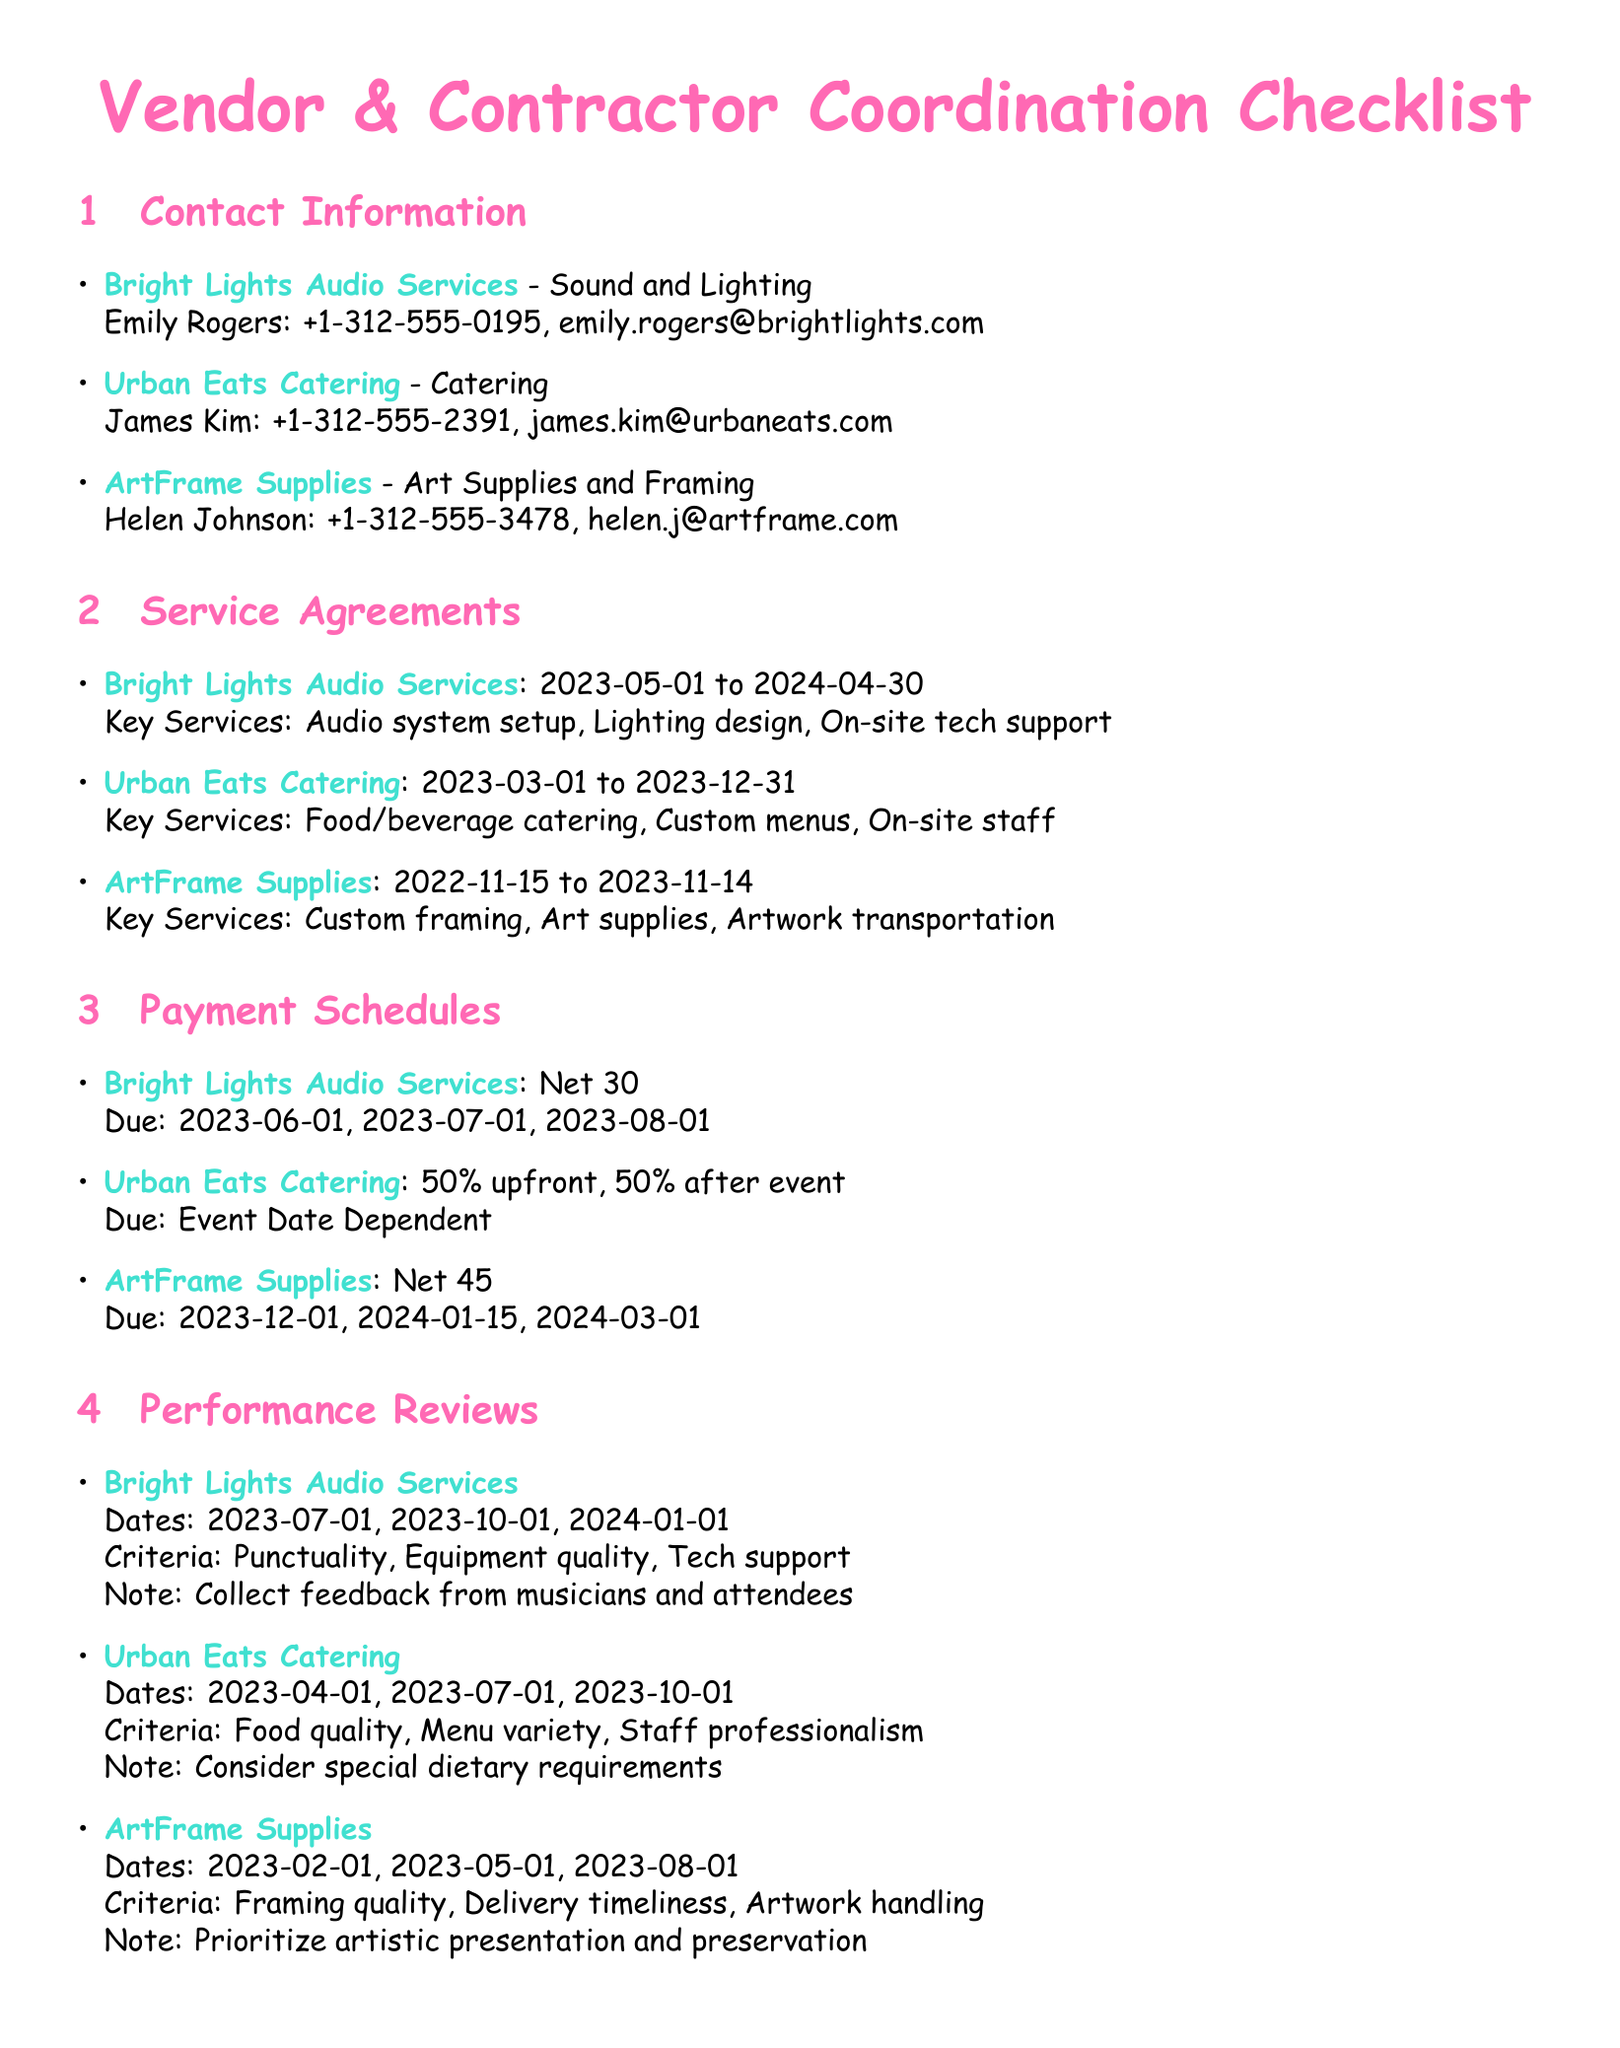what is the contact number for Urban Eats Catering? The contact number is the specific information provided for Urban Eats Catering among other vendors in the checklist.
Answer: +1-312-555-2391 what is the service end date for Bright Lights Audio Services? The service end date is mentioned in the service agreements section for Bright Lights Audio Services.
Answer: 2024-04-30 how often are payments due for ArtFrame Supplies? This question requires synthesizing the payment schedule details for ArtFrame Supplies to determine the payment frequency.
Answer: Net 45 what is the performance review criteria for Urban Eats Catering? The specific criteria can be found in the performance reviews section under Urban Eats Catering.
Answer: Food quality, Menu variety, Staff professionalism who is responsible for artwork transportation? This asks for the specific services provided by ArtFrame Supplies which includes certain responsibilities listed in the service agreements.
Answer: ArtFrame Supplies 